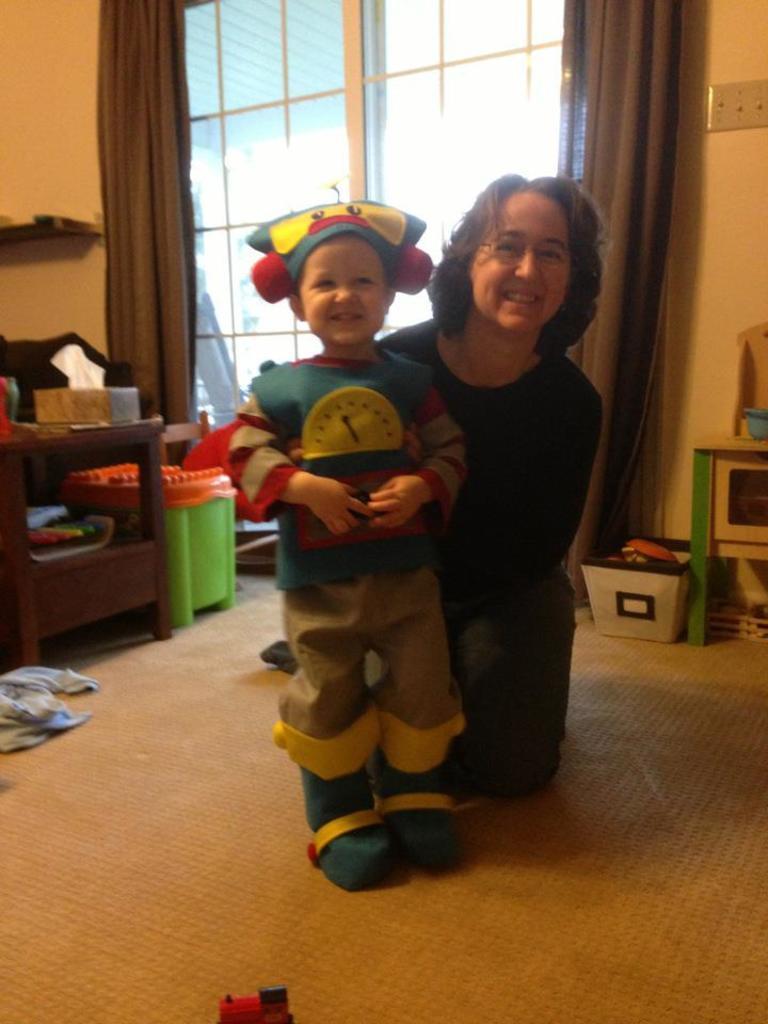How would you summarize this image in a sentence or two? In this image I can see two persons. The person at right wearing black shirt and the person at left wearing blue shirt and brown pant. Background I can see a stool, curtain in brown color, a window, and wall is in cream color. 